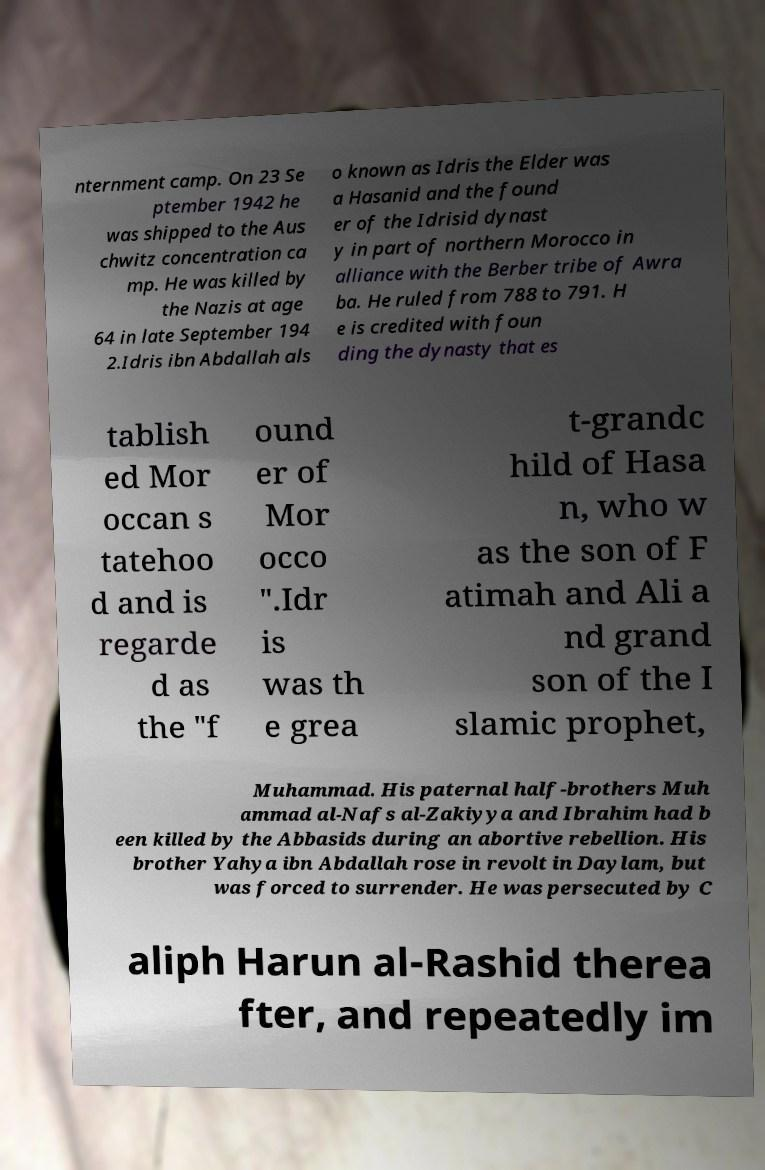There's text embedded in this image that I need extracted. Can you transcribe it verbatim? nternment camp. On 23 Se ptember 1942 he was shipped to the Aus chwitz concentration ca mp. He was killed by the Nazis at age 64 in late September 194 2.Idris ibn Abdallah als o known as Idris the Elder was a Hasanid and the found er of the Idrisid dynast y in part of northern Morocco in alliance with the Berber tribe of Awra ba. He ruled from 788 to 791. H e is credited with foun ding the dynasty that es tablish ed Mor occan s tatehoo d and is regarde d as the "f ound er of Mor occo ".Idr is was th e grea t-grandc hild of Hasa n, who w as the son of F atimah and Ali a nd grand son of the I slamic prophet, Muhammad. His paternal half-brothers Muh ammad al-Nafs al-Zakiyya and Ibrahim had b een killed by the Abbasids during an abortive rebellion. His brother Yahya ibn Abdallah rose in revolt in Daylam, but was forced to surrender. He was persecuted by C aliph Harun al-Rashid therea fter, and repeatedly im 